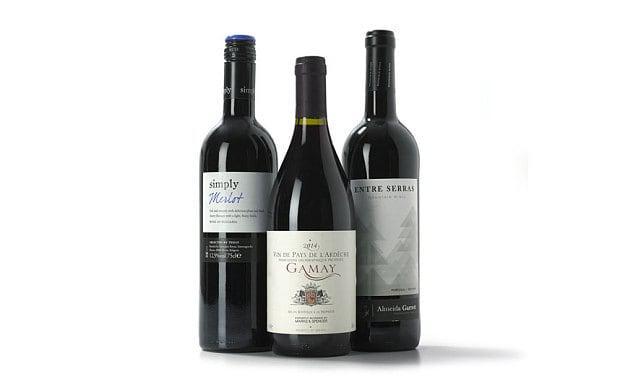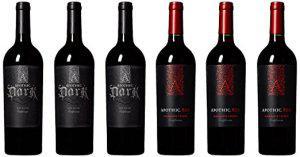The first image is the image on the left, the second image is the image on the right. Evaluate the accuracy of this statement regarding the images: "Two bottles of wine, one in each image, are sealed closed and have different labels on the body of the bottle.". Is it true? Answer yes or no. No. 